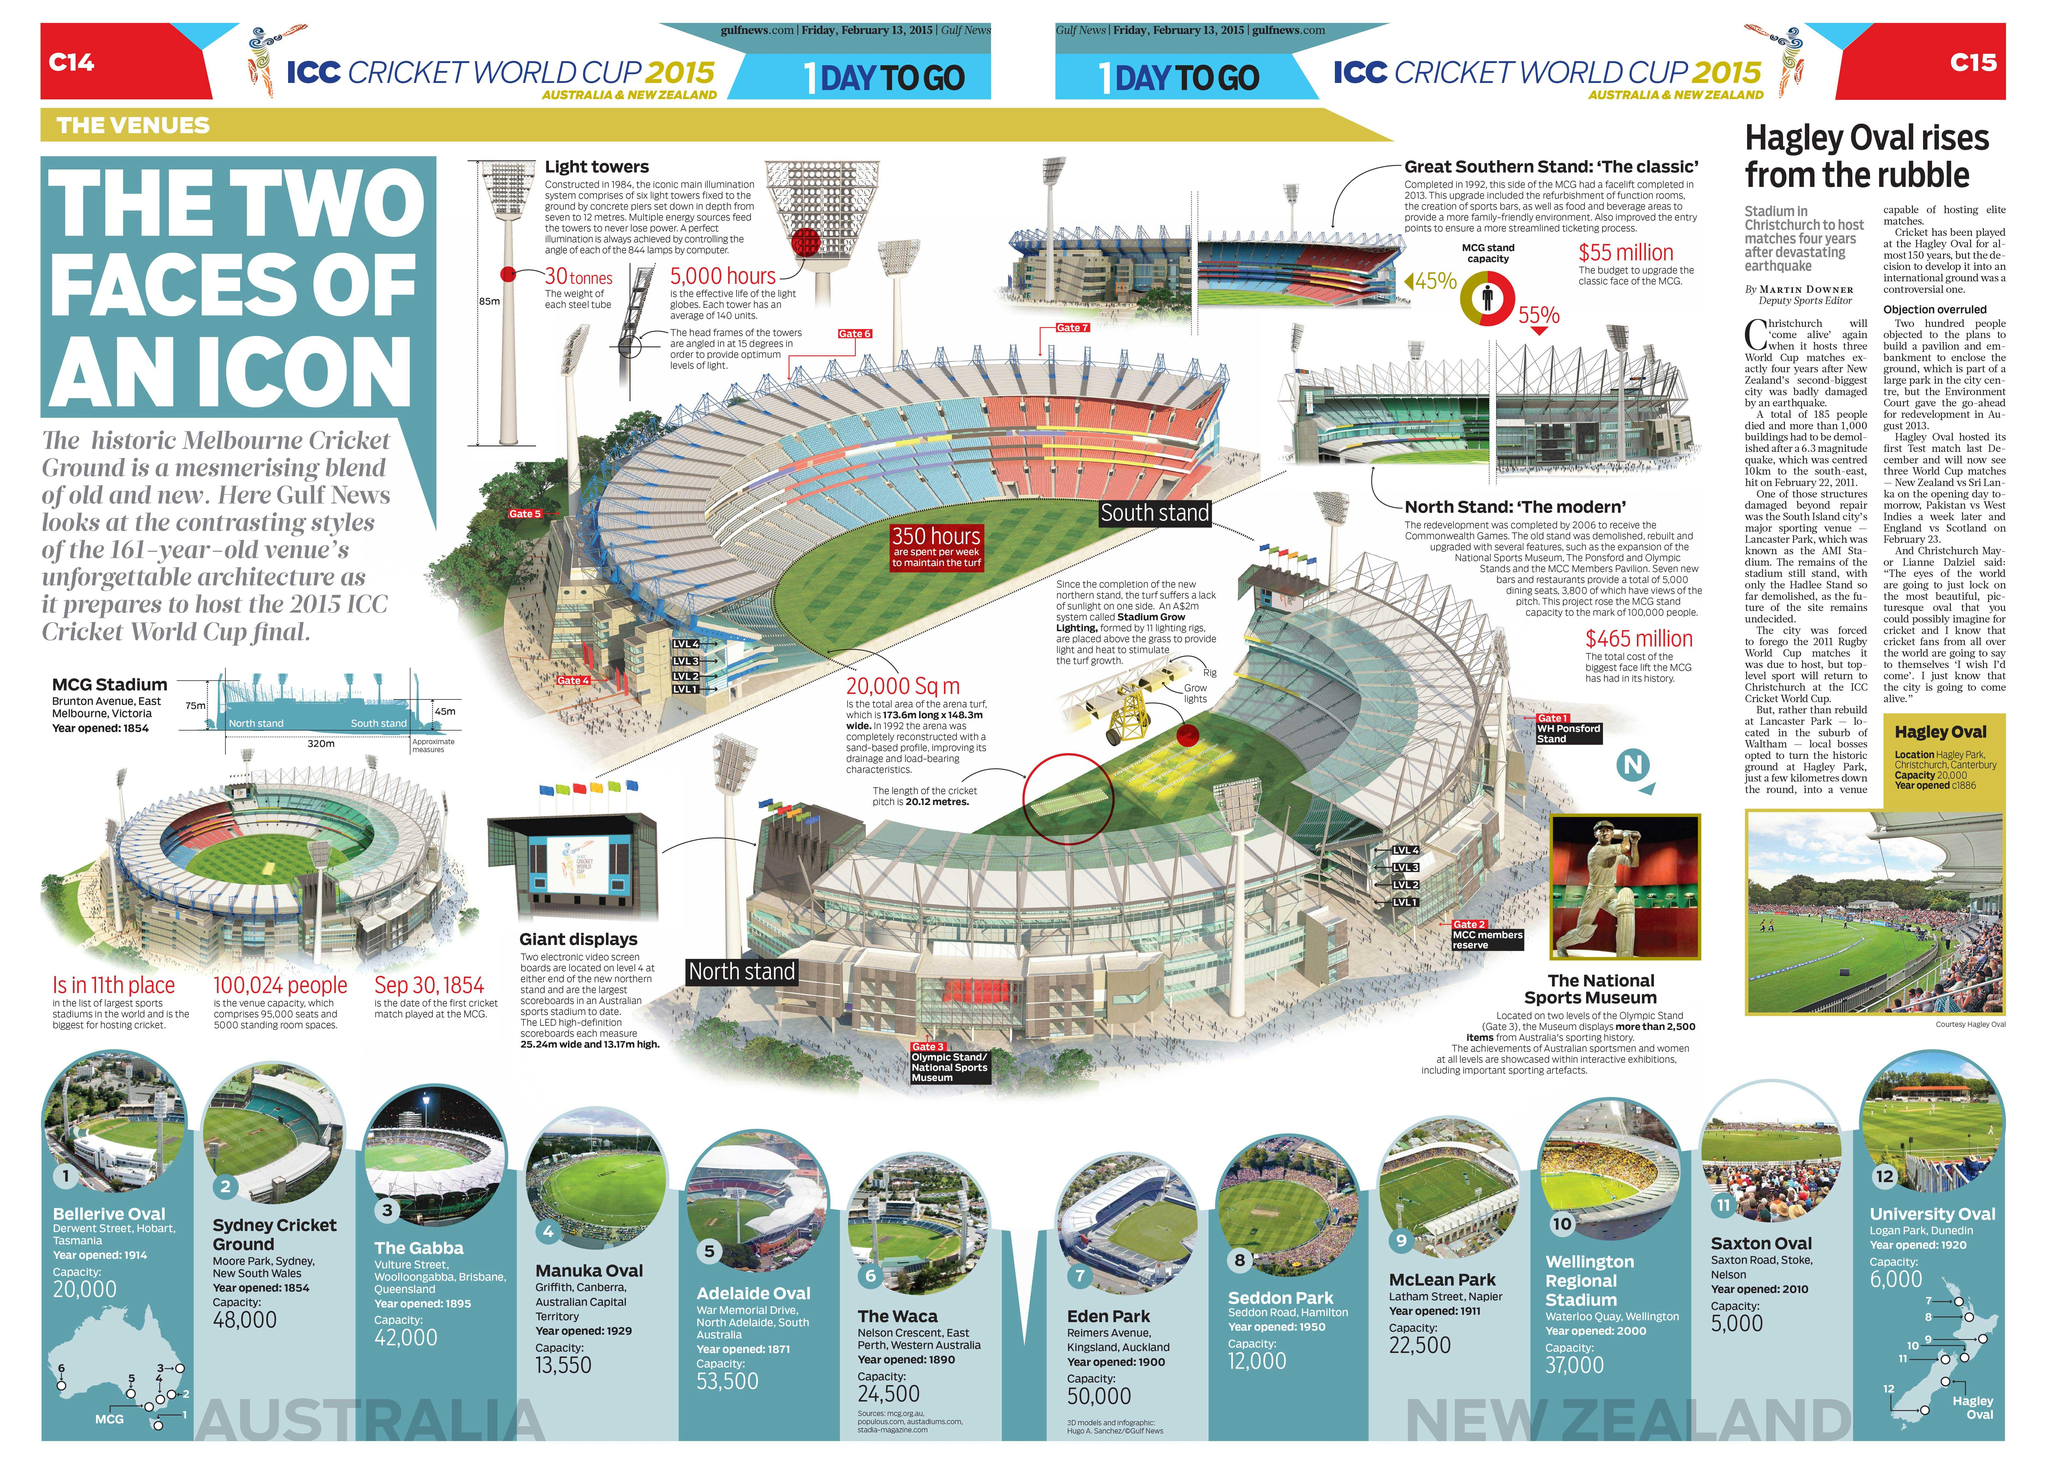Mention a couple of crucial points in this snapshot. There are two stadiums that have a capacity of more than or equal to 50,000. Out of the total number of stadiums, approximately 4 have a capacity of less than 20,000. There are 7 stadiums that have a capacity of 20,000 to 50,000. The number of stadiums opened before 1901 is five. After 1901, 7 stadiums were opened. 